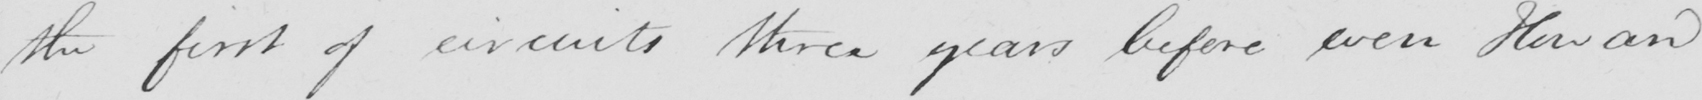What does this handwritten line say? the first of circuits three years before even Howard 